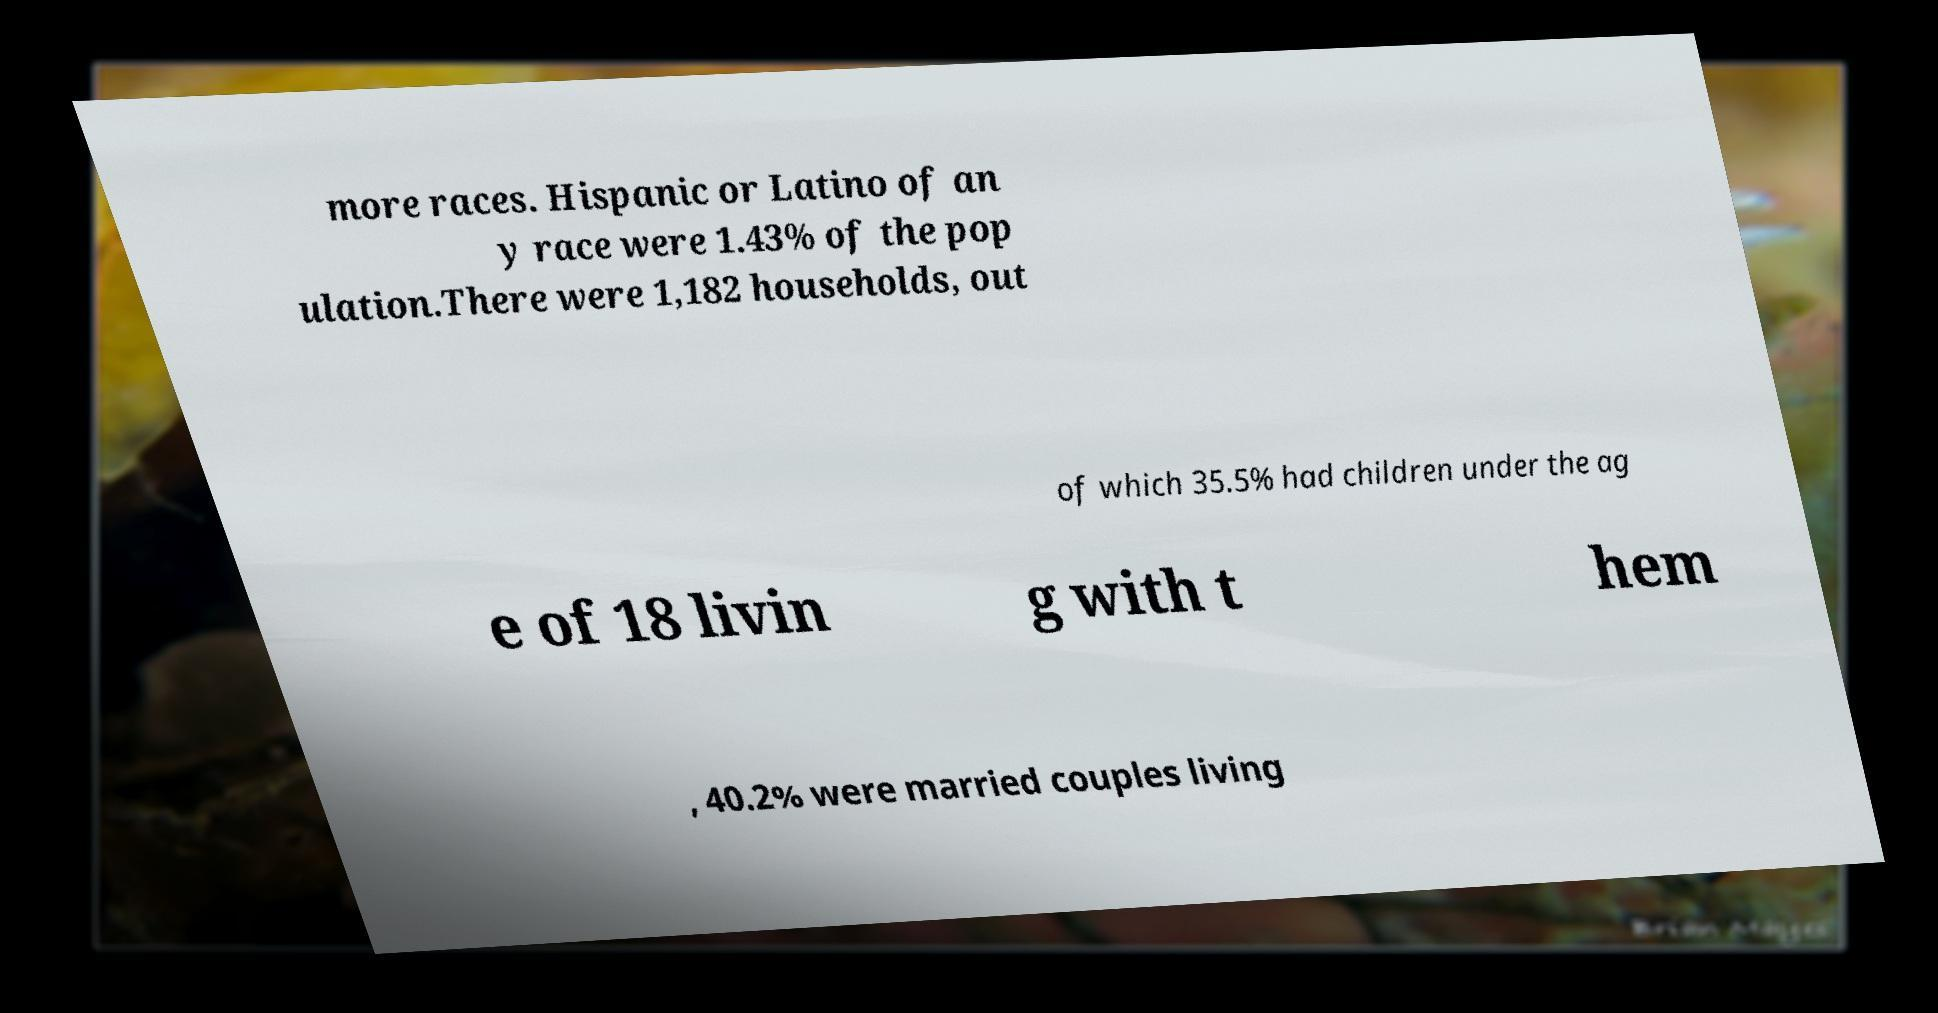I need the written content from this picture converted into text. Can you do that? more races. Hispanic or Latino of an y race were 1.43% of the pop ulation.There were 1,182 households, out of which 35.5% had children under the ag e of 18 livin g with t hem , 40.2% were married couples living 